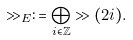<formula> <loc_0><loc_0><loc_500><loc_500>\gg _ { E } \colon = \bigoplus _ { i \in \mathbb { Z } } \gg ( 2 i ) .</formula> 